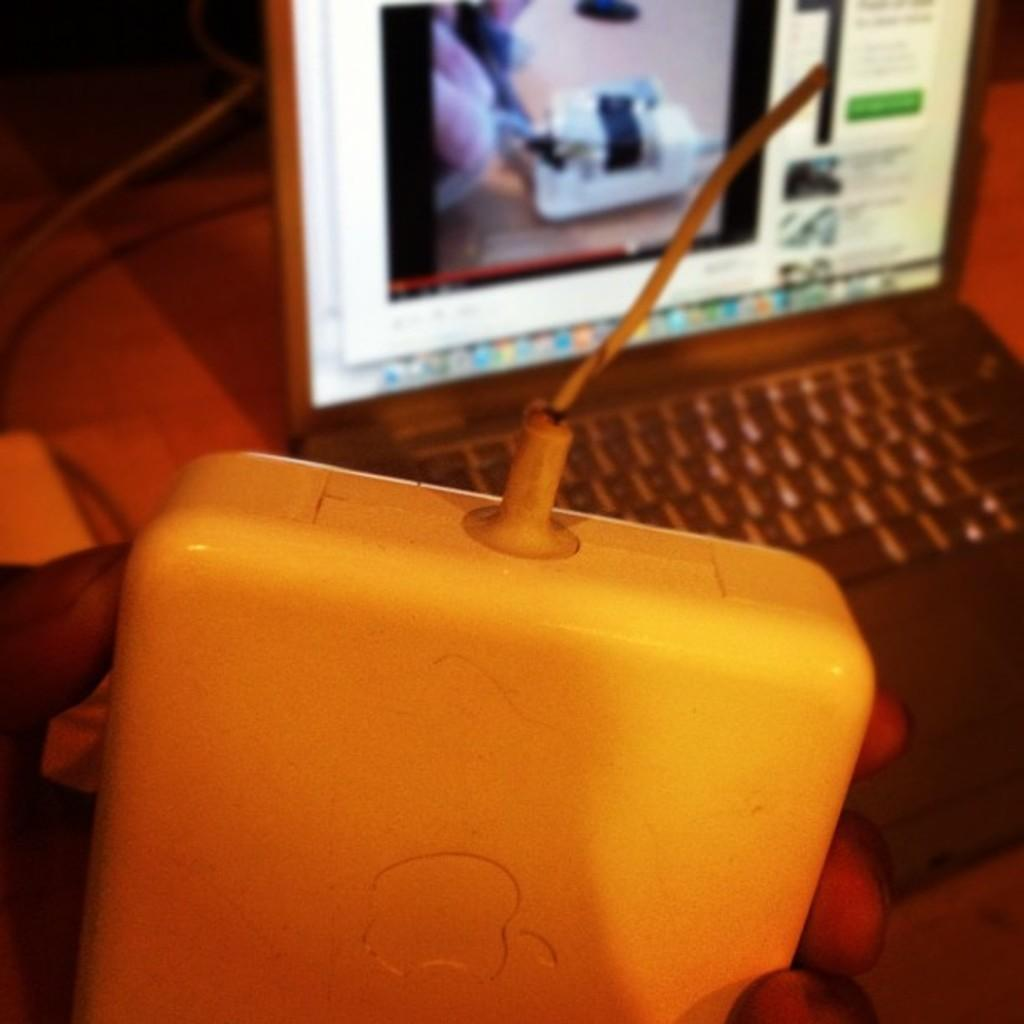What is the person's hand holding in the image? The person's hand is holding an adapter in the image. What can be seen on the table in the image? There is a laptop on the table in the image. What type of beef is being served on the table in the image? There is no beef present in the image; it only features a person's hand holding an adapter and a laptop on a table. 